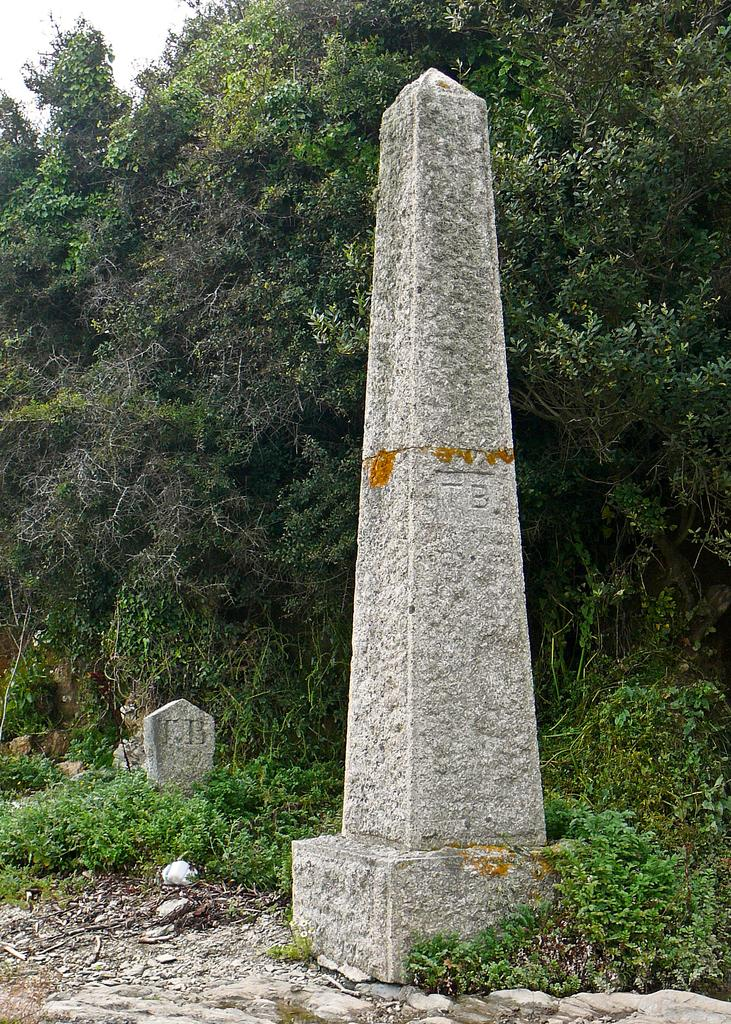What type of structure is present in the picture? There is a column stone in the picture. What other objects can be seen in the picture? There are gravestones in the picture. What can be seen in the background of the picture? There are trees in the background of the picture. What type of floor can be seen in the picture? There is no floor visible in the picture; it features a column stone, gravestones, and trees in the background. Can you see a kitten playing among the gravestones in the picture? There is no kitten present in the image. 